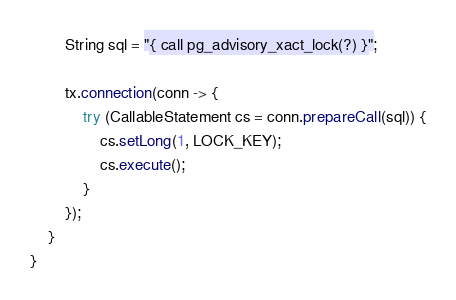<code> <loc_0><loc_0><loc_500><loc_500><_Java_>        String sql = "{ call pg_advisory_xact_lock(?) }";

        tx.connection(conn -> {
            try (CallableStatement cs = conn.prepareCall(sql)) {
                cs.setLong(1, LOCK_KEY);
                cs.execute();
            }
        });
    }
}
</code> 